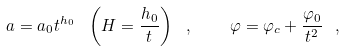Convert formula to latex. <formula><loc_0><loc_0><loc_500><loc_500>a = a _ { 0 } t ^ { h _ { 0 } } \ \left ( H = \frac { h _ { 0 } } { t } \right ) \ , \quad \varphi = \varphi _ { c } + \frac { \varphi _ { 0 } } { t ^ { 2 } } \ ,</formula> 